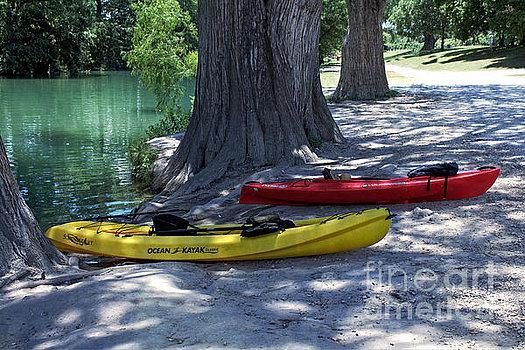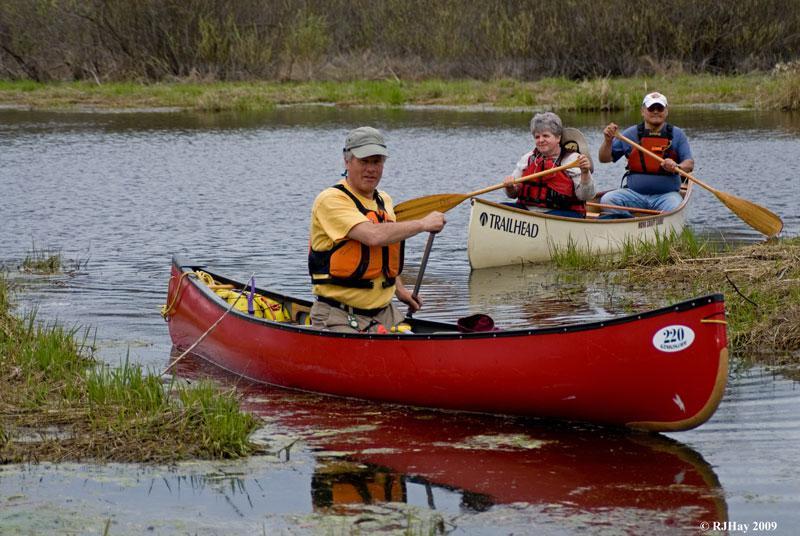The first image is the image on the left, the second image is the image on the right. For the images shown, is this caption "One image shows side-by-side canoes joined with just two simple poles and not floating on water." true? Answer yes or no. No. The first image is the image on the left, the second image is the image on the right. Examine the images to the left and right. Is the description "There are a minimum of four boats." accurate? Answer yes or no. Yes. 